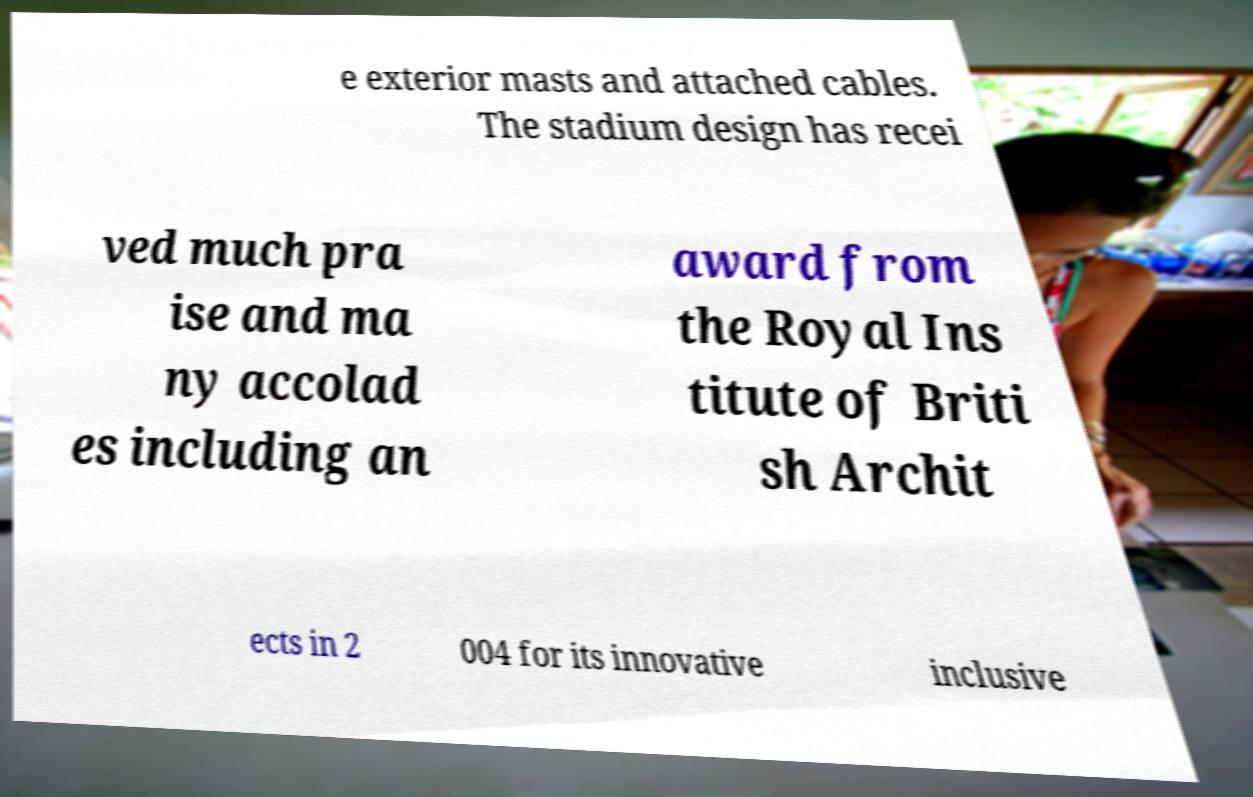I need the written content from this picture converted into text. Can you do that? e exterior masts and attached cables. The stadium design has recei ved much pra ise and ma ny accolad es including an award from the Royal Ins titute of Briti sh Archit ects in 2 004 for its innovative inclusive 